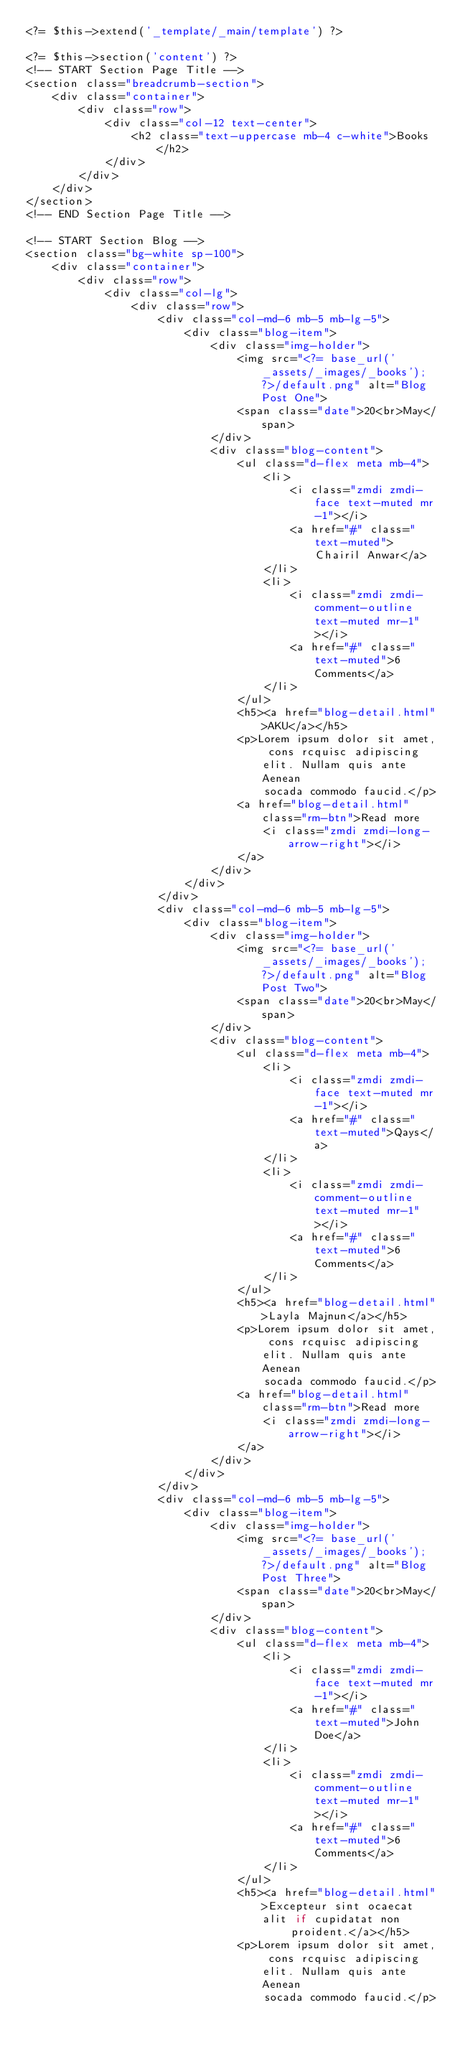<code> <loc_0><loc_0><loc_500><loc_500><_PHP_><?= $this->extend('_template/_main/template') ?>

<?= $this->section('content') ?>
<!-- START Section Page Title -->
<section class="breadcrumb-section">
    <div class="container">
        <div class="row">
            <div class="col-12 text-center">
                <h2 class="text-uppercase mb-4 c-white">Books</h2>
            </div>
        </div>
    </div>
</section>
<!-- END Section Page Title -->

<!-- START Section Blog -->
<section class="bg-white sp-100">
    <div class="container">
        <div class="row">
            <div class="col-lg">
                <div class="row">
                    <div class="col-md-6 mb-5 mb-lg-5">
                        <div class="blog-item">
                            <div class="img-holder">
                                <img src="<?= base_url('_assets/_images/_books'); ?>/default.png" alt="Blog Post One">
                                <span class="date">20<br>May</span>
                            </div>
                            <div class="blog-content">
                                <ul class="d-flex meta mb-4">
                                    <li>
                                        <i class="zmdi zmdi-face text-muted mr-1"></i>
                                        <a href="#" class="text-muted">Chairil Anwar</a>
                                    </li>
                                    <li>
                                        <i class="zmdi zmdi-comment-outline text-muted mr-1"></i>
                                        <a href="#" class="text-muted">6 Comments</a>
                                    </li>
                                </ul>
                                <h5><a href="blog-detail.html">AKU</a></h5>
                                <p>Lorem ipsum dolor sit amet, cons rcquisc adipiscing elit. Nullam quis ante Aenean
                                    socada commodo faucid.</p>
                                <a href="blog-detail.html" class="rm-btn">Read more
                                    <i class="zmdi zmdi-long-arrow-right"></i>
                                </a>
                            </div>
                        </div>
                    </div>
                    <div class="col-md-6 mb-5 mb-lg-5">
                        <div class="blog-item">
                            <div class="img-holder">
                                <img src="<?= base_url('_assets/_images/_books'); ?>/default.png" alt="Blog Post Two">
                                <span class="date">20<br>May</span>
                            </div>
                            <div class="blog-content">
                                <ul class="d-flex meta mb-4">
                                    <li>
                                        <i class="zmdi zmdi-face text-muted mr-1"></i>
                                        <a href="#" class="text-muted">Qays</a>
                                    </li>
                                    <li>
                                        <i class="zmdi zmdi-comment-outline text-muted mr-1"></i>
                                        <a href="#" class="text-muted">6 Comments</a>
                                    </li>
                                </ul>
                                <h5><a href="blog-detail.html">Layla Majnun</a></h5>
                                <p>Lorem ipsum dolor sit amet, cons rcquisc adipiscing elit. Nullam quis ante Aenean
                                    socada commodo faucid.</p>
                                <a href="blog-detail.html" class="rm-btn">Read more
                                    <i class="zmdi zmdi-long-arrow-right"></i>
                                </a>
                            </div>
                        </div>
                    </div>
                    <div class="col-md-6 mb-5 mb-lg-5">
                        <div class="blog-item">
                            <div class="img-holder">
                                <img src="<?= base_url('_assets/_images/_books'); ?>/default.png" alt="Blog Post Three">
                                <span class="date">20<br>May</span>
                            </div>
                            <div class="blog-content">
                                <ul class="d-flex meta mb-4">
                                    <li>
                                        <i class="zmdi zmdi-face text-muted mr-1"></i>
                                        <a href="#" class="text-muted">John Doe</a>
                                    </li>
                                    <li>
                                        <i class="zmdi zmdi-comment-outline text-muted mr-1"></i>
                                        <a href="#" class="text-muted">6 Comments</a>
                                    </li>
                                </ul>
                                <h5><a href="blog-detail.html">Excepteur sint ocaecat alit if cupidatat non
                                        proident.</a></h5>
                                <p>Lorem ipsum dolor sit amet, cons rcquisc adipiscing elit. Nullam quis ante Aenean
                                    socada commodo faucid.</p></code> 